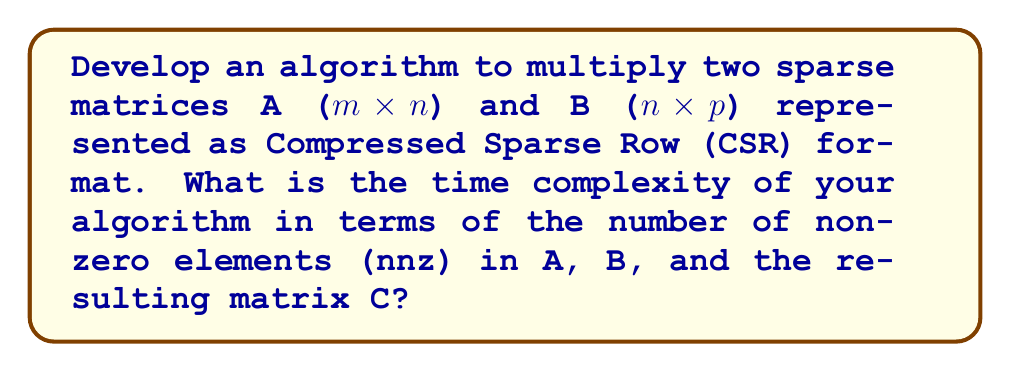Solve this math problem. To optimize matrix multiplication for sparse matrices, we can use the Compressed Sparse Row (CSR) format, which is commonly used in Java libraries for efficient sparse matrix operations.

1. CSR representation:
   - For each matrix, store three arrays:
     a. values: contains non-zero elements
     b. column_indices: contains column indices of non-zero elements
     c. row_pointers: contains starting indices of each row in values array

2. Algorithm steps:
   a. Initialize an empty result matrix C in CSR format
   b. For each non-zero element A[i,k] in matrix A:
      - For each non-zero element B[k,j] in matrix B:
        - Accumulate the product A[i,k] * B[k,j] to C[i,j]
   c. Compress the result matrix C into CSR format

3. Time complexity analysis:
   - Let nnz(A), nnz(B), and nnz(C) be the number of non-zero elements in A, B, and C respectively
   - For each non-zero element in A, we potentially traverse all non-zero elements in the corresponding row of B
   - The total number of operations is proportional to:
     $$\sum_{i=1}^m \sum_{k: A[i,k] \neq 0} \text{nnz}(B_k)$$
     where $B_k$ is the k-th row of B

   - In the worst case, this can be O(nnz(A) * nnz(B))
   - However, the actual complexity is often much lower due to sparsity

4. Implementation considerations:
   - Use efficient data structures like HashMaps to accumulate results before compressing to CSR
   - Implement using Java, possibly utilizing existing sparse matrix libraries
   - Consider using ANT for build automation and dependency management

The final time complexity depends on the sparsity pattern of both input matrices and the resulting matrix. In practice, it's often closer to O(nnz(A) + nnz(B) + nnz(C)) for very sparse matrices.
Answer: The time complexity of the optimized sparse matrix multiplication algorithm is O(nnz(A) * nnz(B)) in the worst case, but is often closer to O(nnz(A) + nnz(B) + nnz(C)) in practice for very sparse matrices, where nnz(X) represents the number of non-zero elements in matrix X. 